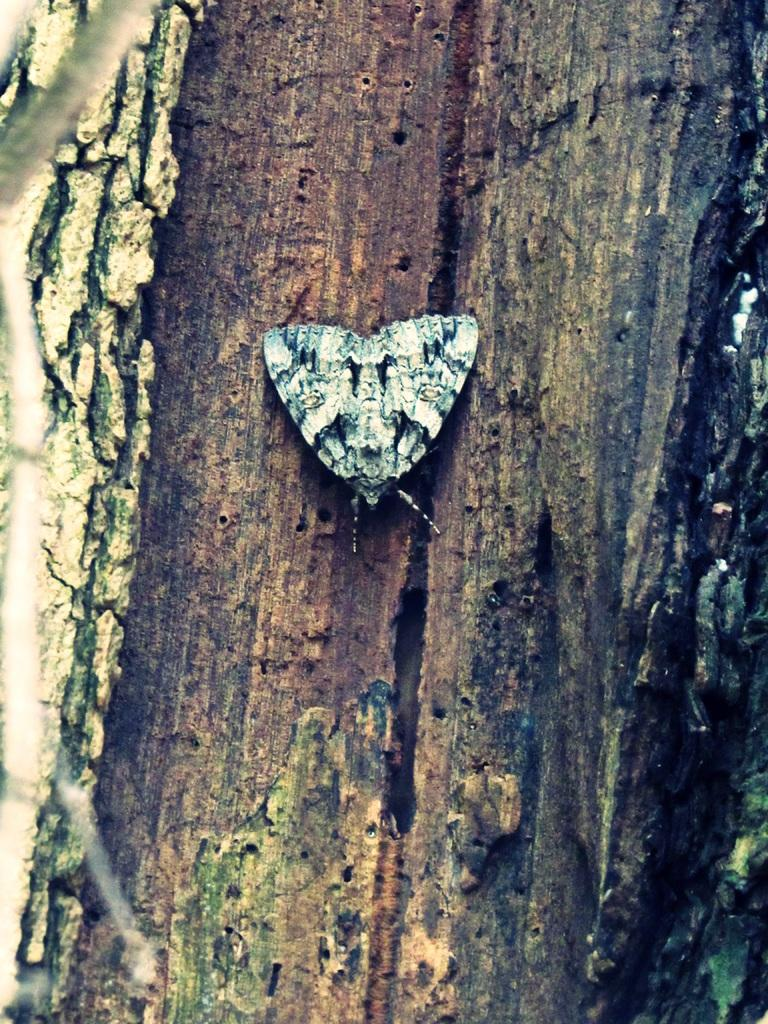What type of creature can be seen in the image? There is an insect in the image. Where is the insect located? The insect is on a surface that resembles a tree trunk. What type of coast can be seen in the image? There is no coast present in the image; it features an insect on a surface that resembles a tree trunk. What kind of toy is being used as bait in the image? There is no toy or bait present in the image; it only shows an insect on a tree trunk-like surface. 